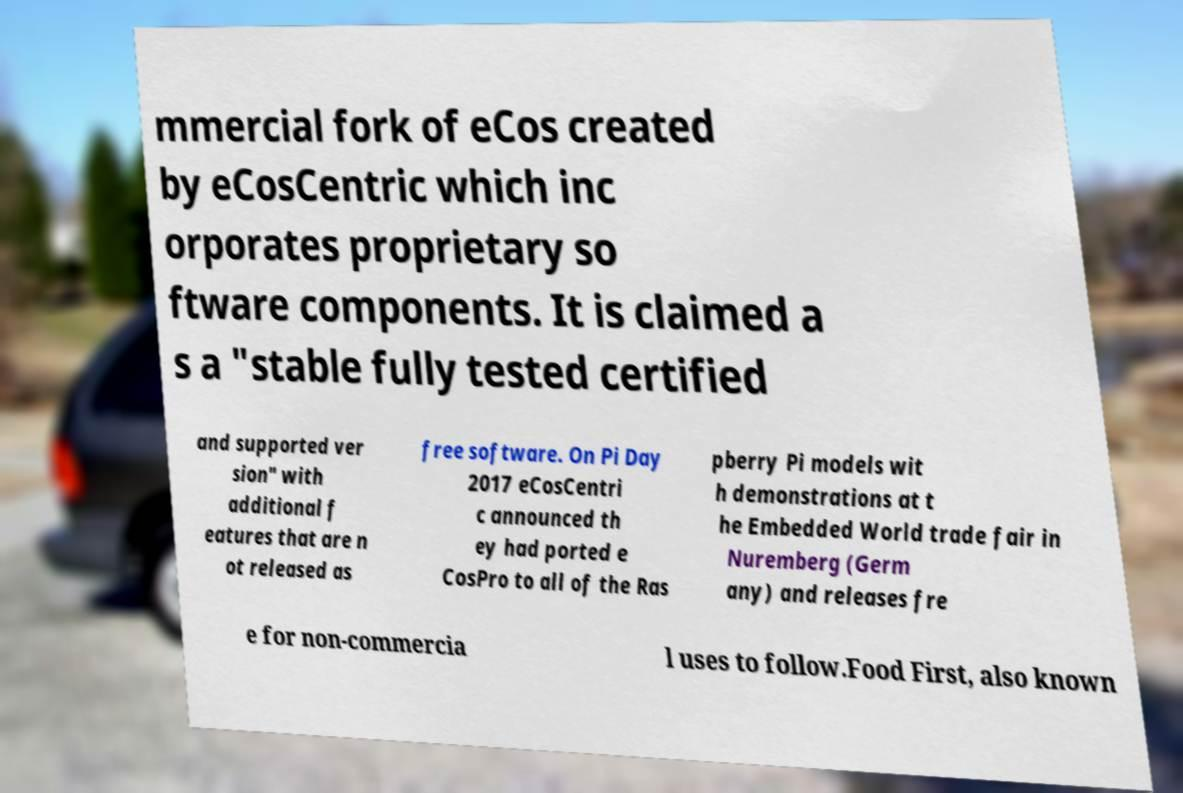What messages or text are displayed in this image? I need them in a readable, typed format. mmercial fork of eCos created by eCosCentric which inc orporates proprietary so ftware components. It is claimed a s a "stable fully tested certified and supported ver sion" with additional f eatures that are n ot released as free software. On Pi Day 2017 eCosCentri c announced th ey had ported e CosPro to all of the Ras pberry Pi models wit h demonstrations at t he Embedded World trade fair in Nuremberg (Germ any) and releases fre e for non-commercia l uses to follow.Food First, also known 